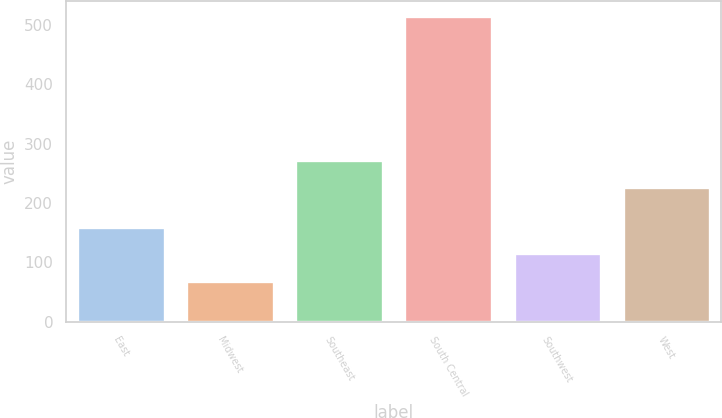<chart> <loc_0><loc_0><loc_500><loc_500><bar_chart><fcel>East<fcel>Midwest<fcel>Southeast<fcel>South Central<fcel>Southwest<fcel>West<nl><fcel>159.64<fcel>68.7<fcel>271.84<fcel>514.1<fcel>115.1<fcel>227.3<nl></chart> 